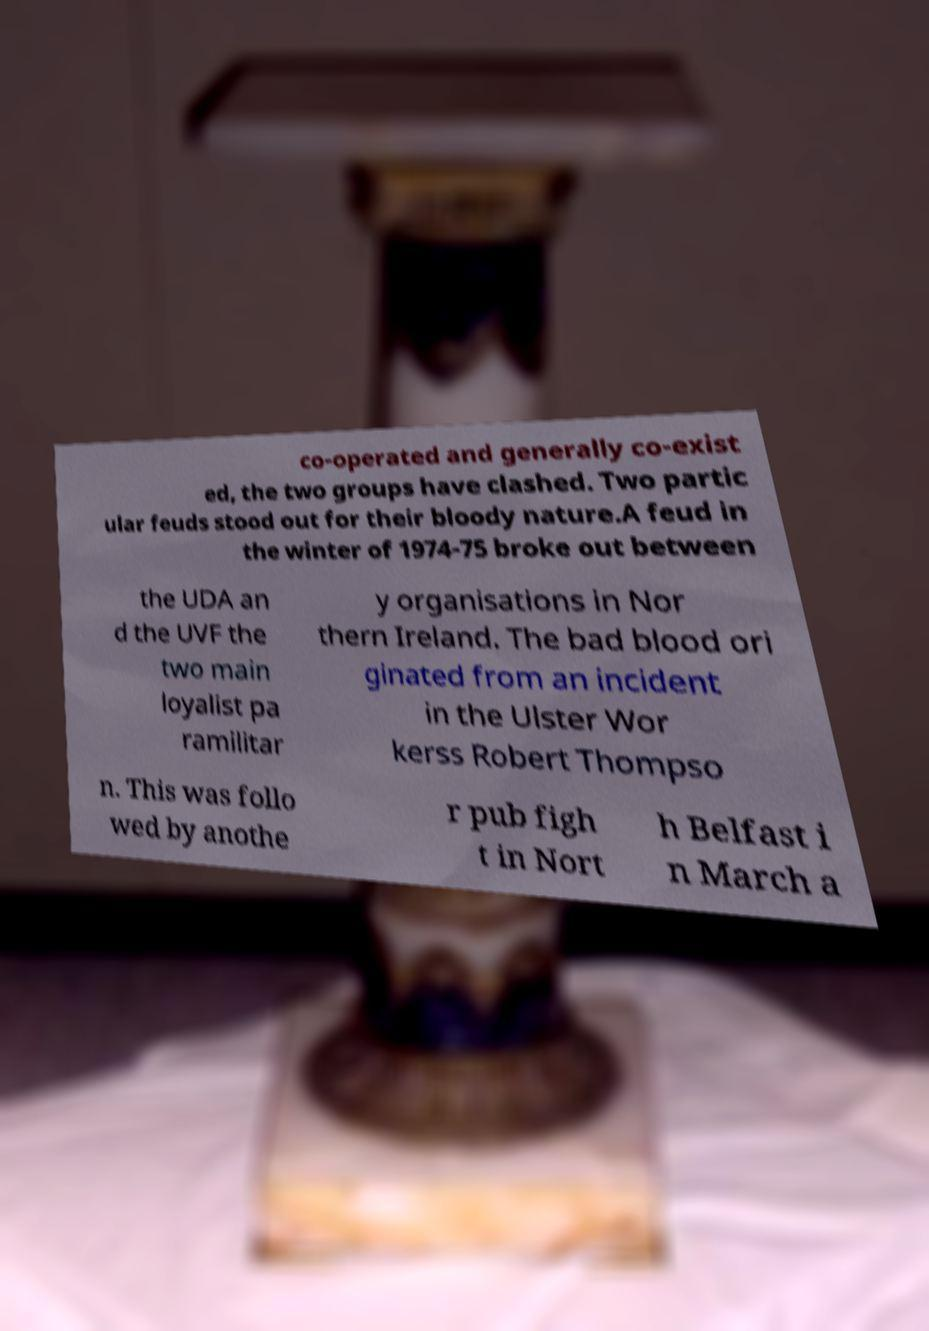What messages or text are displayed in this image? I need them in a readable, typed format. co-operated and generally co-exist ed, the two groups have clashed. Two partic ular feuds stood out for their bloody nature.A feud in the winter of 1974-75 broke out between the UDA an d the UVF the two main loyalist pa ramilitar y organisations in Nor thern Ireland. The bad blood ori ginated from an incident in the Ulster Wor kerss Robert Thompso n. This was follo wed by anothe r pub figh t in Nort h Belfast i n March a 